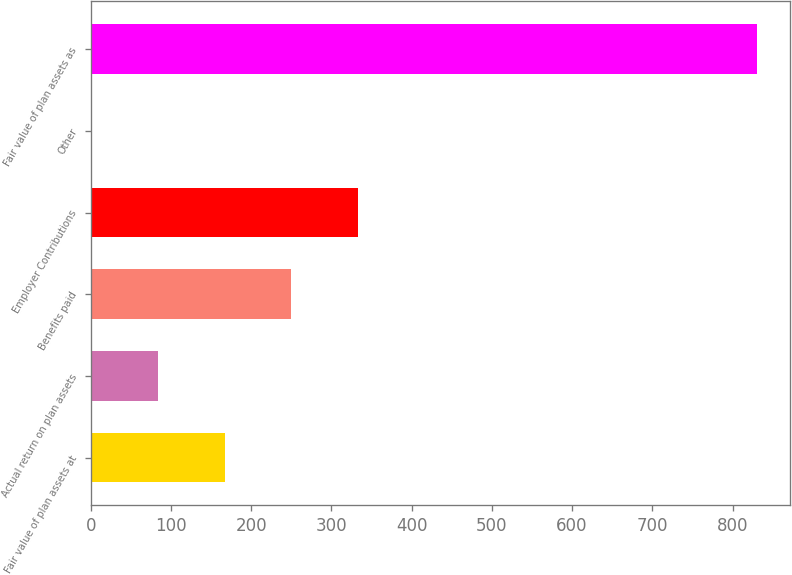<chart> <loc_0><loc_0><loc_500><loc_500><bar_chart><fcel>Fair value of plan assets at<fcel>Actual return on plan assets<fcel>Benefits paid<fcel>Employer Contributions<fcel>Other<fcel>Fair value of plan assets as<nl><fcel>166.8<fcel>83.9<fcel>249.7<fcel>332.6<fcel>1<fcel>830<nl></chart> 